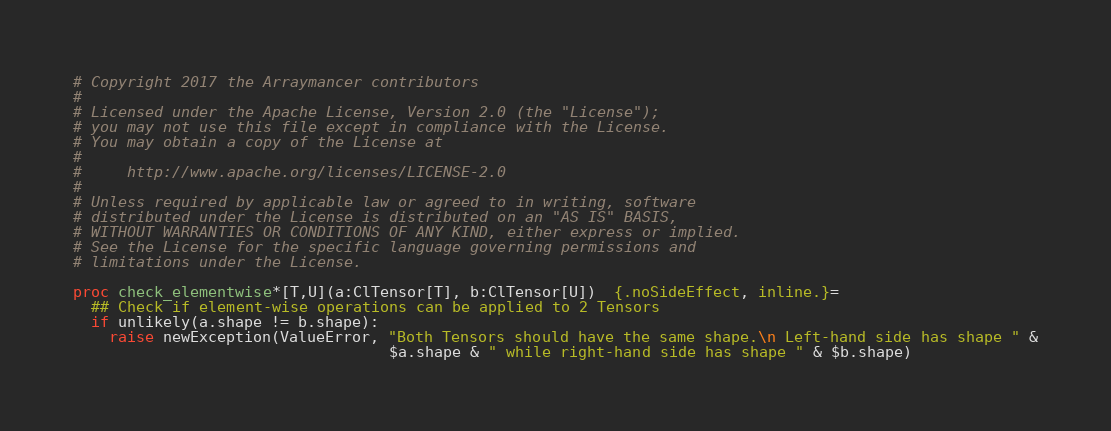<code> <loc_0><loc_0><loc_500><loc_500><_Nim_># Copyright 2017 the Arraymancer contributors
#
# Licensed under the Apache License, Version 2.0 (the "License");
# you may not use this file except in compliance with the License.
# You may obtain a copy of the License at
#
#     http://www.apache.org/licenses/LICENSE-2.0
#
# Unless required by applicable law or agreed to in writing, software
# distributed under the License is distributed on an "AS IS" BASIS,
# WITHOUT WARRANTIES OR CONDITIONS OF ANY KIND, either express or implied.
# See the License for the specific language governing permissions and
# limitations under the License.

proc check_elementwise*[T,U](a:ClTensor[T], b:ClTensor[U])  {.noSideEffect, inline.}=
  ## Check if element-wise operations can be applied to 2 Tensors
  if unlikely(a.shape != b.shape):
    raise newException(ValueError, "Both Tensors should have the same shape.\n Left-hand side has shape " &
                                   $a.shape & " while right-hand side has shape " & $b.shape)</code> 